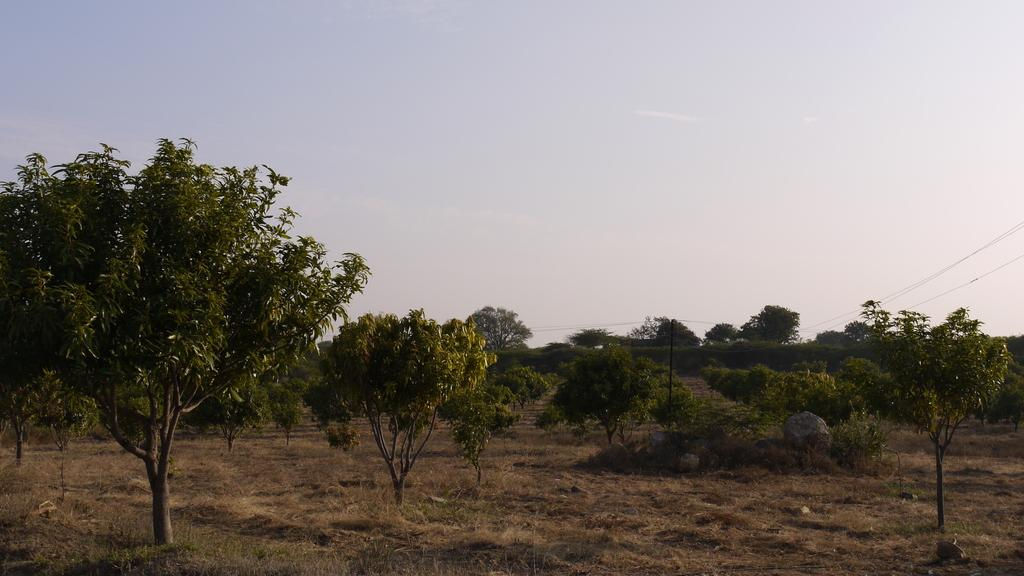What type of vegetation can be seen in the image? There are trees in the image. What else can be seen on the ground in the image? There is grass in the image. What man-made structure is present in the image? There is an electric pole with cables in the image. What is visible in the background of the image? The sky is visible behind the trees in the image. What type of property is being sold in the image? There is no indication of any property being sold in the image. Can you tell me how many tubs are visible in the image? There are no tubs present in the image. 